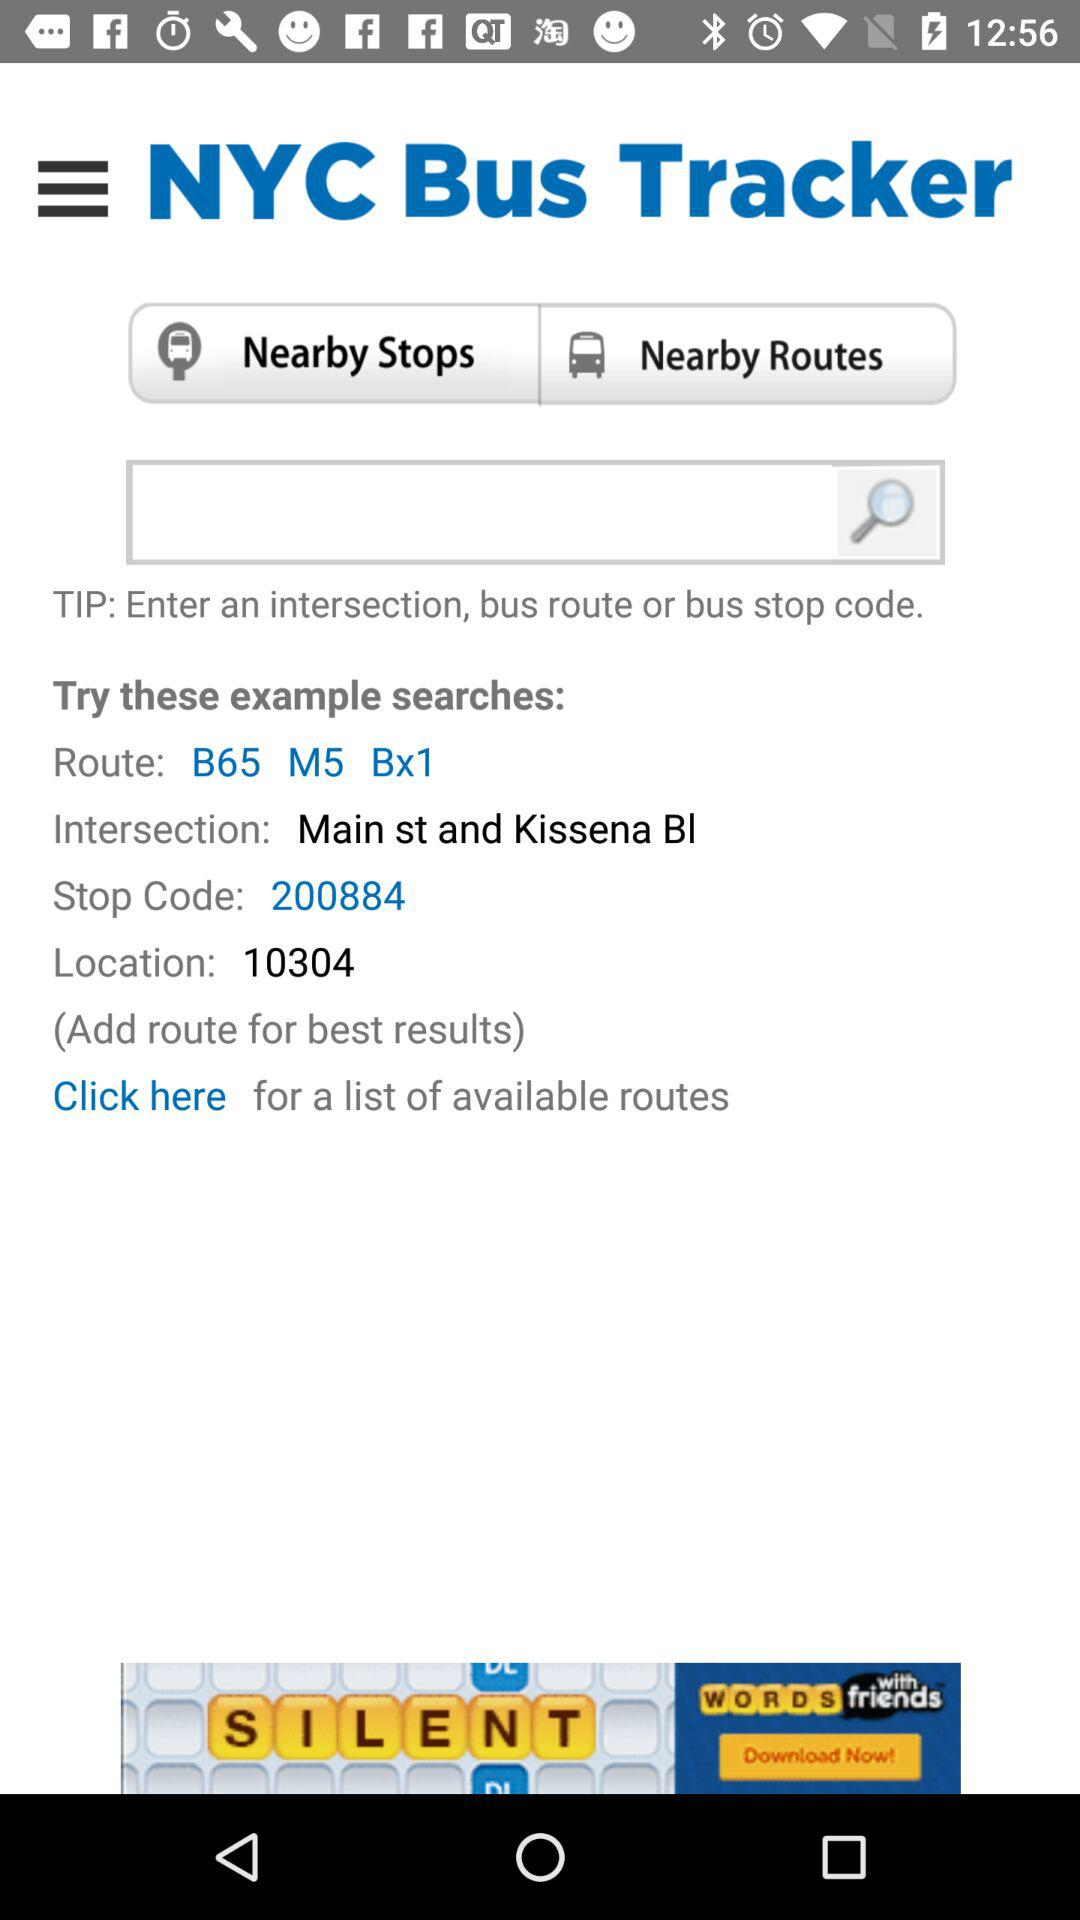What is the location code? The location code is 10304. 